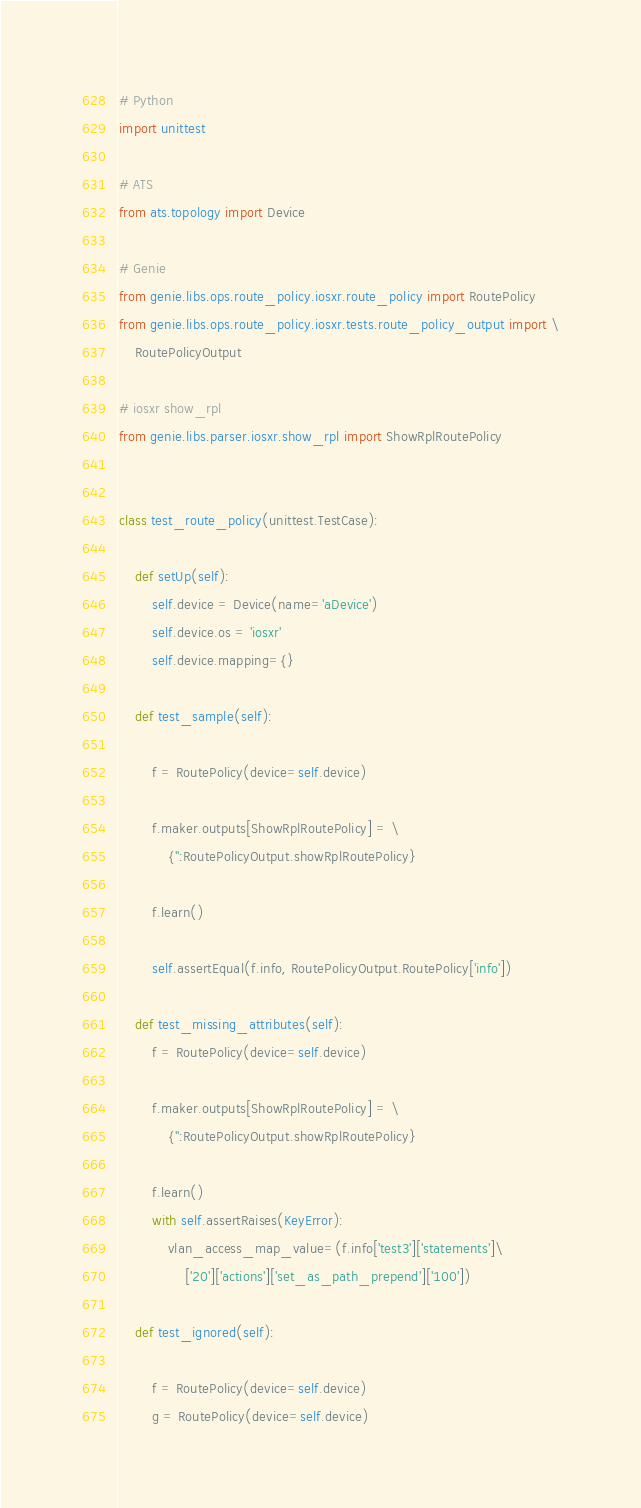Convert code to text. <code><loc_0><loc_0><loc_500><loc_500><_Python_># Python
import unittest

# ATS
from ats.topology import Device

# Genie
from genie.libs.ops.route_policy.iosxr.route_policy import RoutePolicy
from genie.libs.ops.route_policy.iosxr.tests.route_policy_output import \
    RoutePolicyOutput

# iosxr show_rpl
from genie.libs.parser.iosxr.show_rpl import ShowRplRoutePolicy


class test_route_policy(unittest.TestCase):

    def setUp(self):
        self.device = Device(name='aDevice')
        self.device.os = 'iosxr'
        self.device.mapping={}

    def test_sample(self):

        f = RoutePolicy(device=self.device)

        f.maker.outputs[ShowRplRoutePolicy] = \
            {'':RoutePolicyOutput.showRplRoutePolicy}

        f.learn()

        self.assertEqual(f.info, RoutePolicyOutput.RoutePolicy['info'])

    def test_missing_attributes(self):
        f = RoutePolicy(device=self.device)

        f.maker.outputs[ShowRplRoutePolicy] = \
            {'':RoutePolicyOutput.showRplRoutePolicy}

        f.learn()
        with self.assertRaises(KeyError):
            vlan_access_map_value=(f.info['test3']['statements']\
                ['20']['actions']['set_as_path_prepend']['100'])

    def test_ignored(self):

        f = RoutePolicy(device=self.device)
        g = RoutePolicy(device=self.device)

</code> 